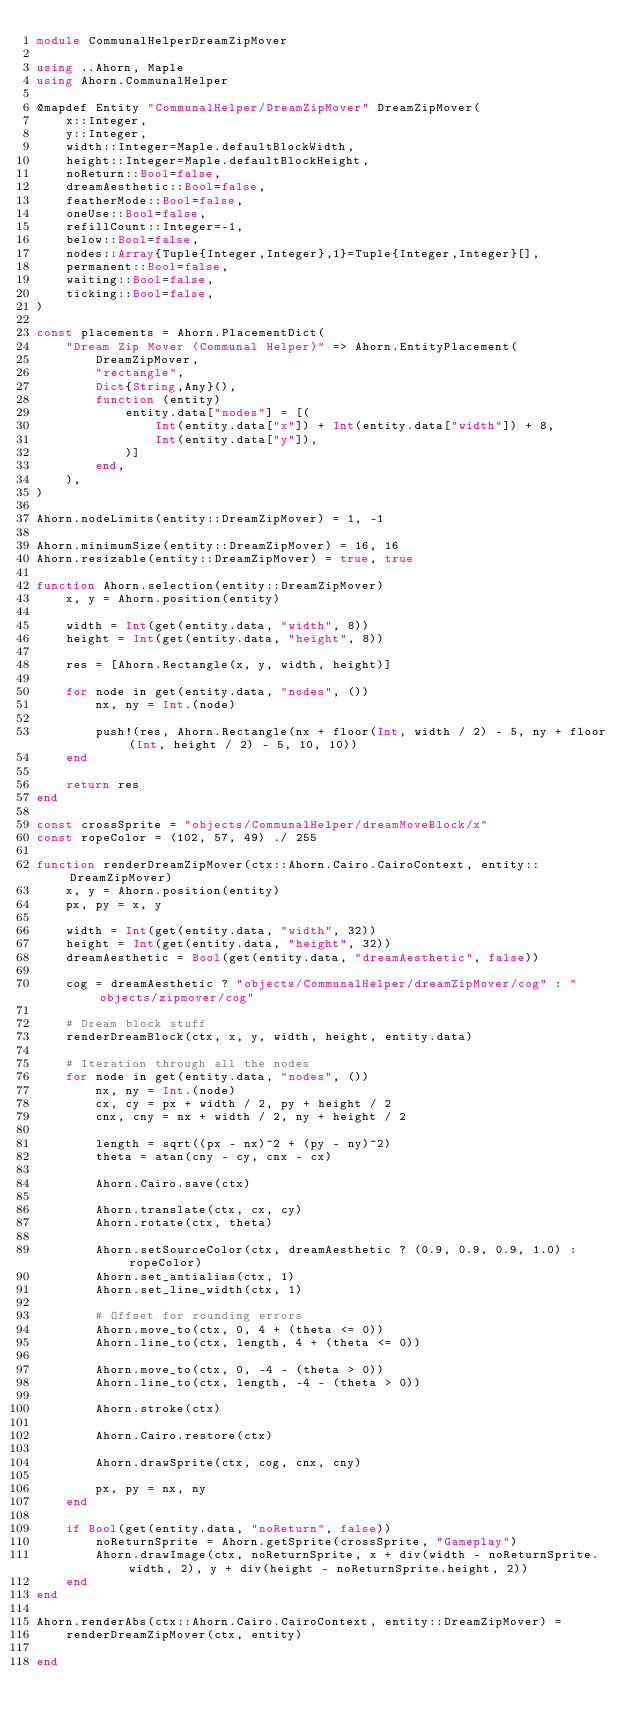Convert code to text. <code><loc_0><loc_0><loc_500><loc_500><_Julia_>module CommunalHelperDreamZipMover

using ..Ahorn, Maple
using Ahorn.CommunalHelper

@mapdef Entity "CommunalHelper/DreamZipMover" DreamZipMover(
    x::Integer,
    y::Integer,
    width::Integer=Maple.defaultBlockWidth,
    height::Integer=Maple.defaultBlockHeight,
    noReturn::Bool=false,
    dreamAesthetic::Bool=false,
    featherMode::Bool=false,
    oneUse::Bool=false,
    refillCount::Integer=-1,
    below::Bool=false,
    nodes::Array{Tuple{Integer,Integer},1}=Tuple{Integer,Integer}[],
    permanent::Bool=false,
    waiting::Bool=false,
    ticking::Bool=false,
)

const placements = Ahorn.PlacementDict(
    "Dream Zip Mover (Communal Helper)" => Ahorn.EntityPlacement(
        DreamZipMover,
        "rectangle",
        Dict{String,Any}(),
        function (entity)
            entity.data["nodes"] = [(
                Int(entity.data["x"]) + Int(entity.data["width"]) + 8,
                Int(entity.data["y"]),
            )]
        end,
    ),
)

Ahorn.nodeLimits(entity::DreamZipMover) = 1, -1

Ahorn.minimumSize(entity::DreamZipMover) = 16, 16
Ahorn.resizable(entity::DreamZipMover) = true, true

function Ahorn.selection(entity::DreamZipMover)
    x, y = Ahorn.position(entity)

    width = Int(get(entity.data, "width", 8))
    height = Int(get(entity.data, "height", 8))

    res = [Ahorn.Rectangle(x, y, width, height)]

    for node in get(entity.data, "nodes", ())
        nx, ny = Int.(node)

        push!(res, Ahorn.Rectangle(nx + floor(Int, width / 2) - 5, ny + floor(Int, height / 2) - 5, 10, 10))
    end

    return res
end

const crossSprite = "objects/CommunalHelper/dreamMoveBlock/x"
const ropeColor = (102, 57, 49) ./ 255

function renderDreamZipMover(ctx::Ahorn.Cairo.CairoContext, entity::DreamZipMover)
    x, y = Ahorn.position(entity)
    px, py = x, y

    width = Int(get(entity.data, "width", 32))
    height = Int(get(entity.data, "height", 32))
    dreamAesthetic = Bool(get(entity.data, "dreamAesthetic", false))

    cog = dreamAesthetic ? "objects/CommunalHelper/dreamZipMover/cog" : "objects/zipmover/cog"

    # Dream block stuff
    renderDreamBlock(ctx, x, y, width, height, entity.data)

    # Iteration through all the nodes
    for node in get(entity.data, "nodes", ())
        nx, ny = Int.(node)
        cx, cy = px + width / 2, py + height / 2
        cnx, cny = nx + width / 2, ny + height / 2

        length = sqrt((px - nx)^2 + (py - ny)^2)
        theta = atan(cny - cy, cnx - cx)

        Ahorn.Cairo.save(ctx)

        Ahorn.translate(ctx, cx, cy)
        Ahorn.rotate(ctx, theta)

        Ahorn.setSourceColor(ctx, dreamAesthetic ? (0.9, 0.9, 0.9, 1.0) : ropeColor)
        Ahorn.set_antialias(ctx, 1)
        Ahorn.set_line_width(ctx, 1)

        # Offset for rounding errors
        Ahorn.move_to(ctx, 0, 4 + (theta <= 0))
        Ahorn.line_to(ctx, length, 4 + (theta <= 0))

        Ahorn.move_to(ctx, 0, -4 - (theta > 0))
        Ahorn.line_to(ctx, length, -4 - (theta > 0))

        Ahorn.stroke(ctx)

        Ahorn.Cairo.restore(ctx)

        Ahorn.drawSprite(ctx, cog, cnx, cny)

        px, py = nx, ny
    end

    if Bool(get(entity.data, "noReturn", false))
        noReturnSprite = Ahorn.getSprite(crossSprite, "Gameplay")
        Ahorn.drawImage(ctx, noReturnSprite, x + div(width - noReturnSprite.width, 2), y + div(height - noReturnSprite.height, 2))
    end
end

Ahorn.renderAbs(ctx::Ahorn.Cairo.CairoContext, entity::DreamZipMover) =
    renderDreamZipMover(ctx, entity)

end
</code> 